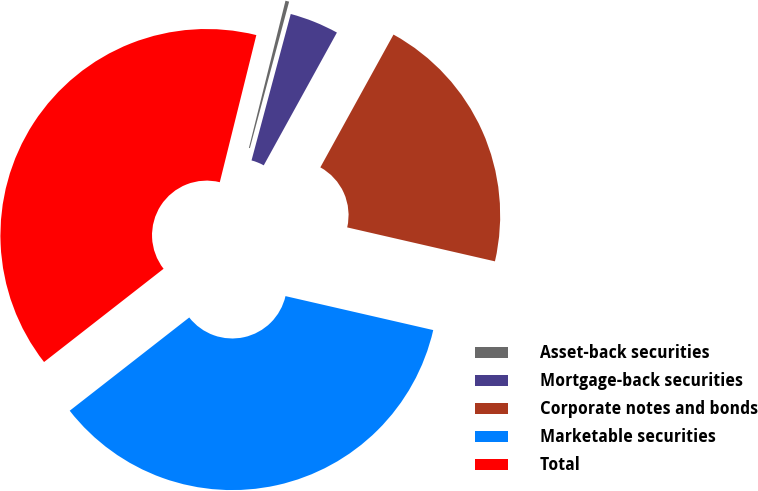Convert chart to OTSL. <chart><loc_0><loc_0><loc_500><loc_500><pie_chart><fcel>Asset-back securities<fcel>Mortgage-back securities<fcel>Corporate notes and bonds<fcel>Marketable securities<fcel>Total<nl><fcel>0.29%<fcel>3.85%<fcel>20.58%<fcel>35.86%<fcel>39.42%<nl></chart> 